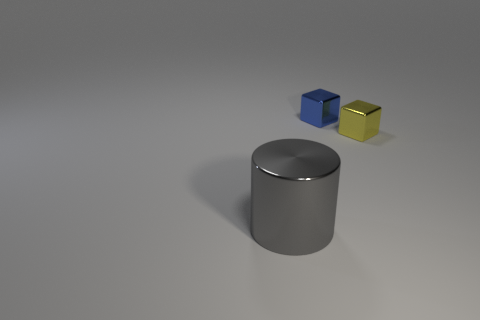Are there any other things that are the same size as the metallic cylinder?
Provide a short and direct response. No. What is the color of the other tiny cube that is made of the same material as the yellow block?
Offer a terse response. Blue. There is a metallic object on the right side of the blue cube; how big is it?
Keep it short and to the point. Small. Does the cylinder have the same material as the yellow block?
Provide a succinct answer. Yes. Are there any blue shiny things to the left of the small cube behind the thing right of the blue metal block?
Your answer should be compact. No. The cylinder is what color?
Make the answer very short. Gray. What color is the cube that is the same size as the blue metallic object?
Keep it short and to the point. Yellow. Does the tiny metal object that is behind the small yellow metallic cube have the same shape as the yellow object?
Provide a short and direct response. Yes. There is a metal object on the right side of the tiny metal object that is behind the cube that is on the right side of the small blue block; what is its color?
Provide a short and direct response. Yellow. Are any yellow objects visible?
Offer a terse response. Yes. 